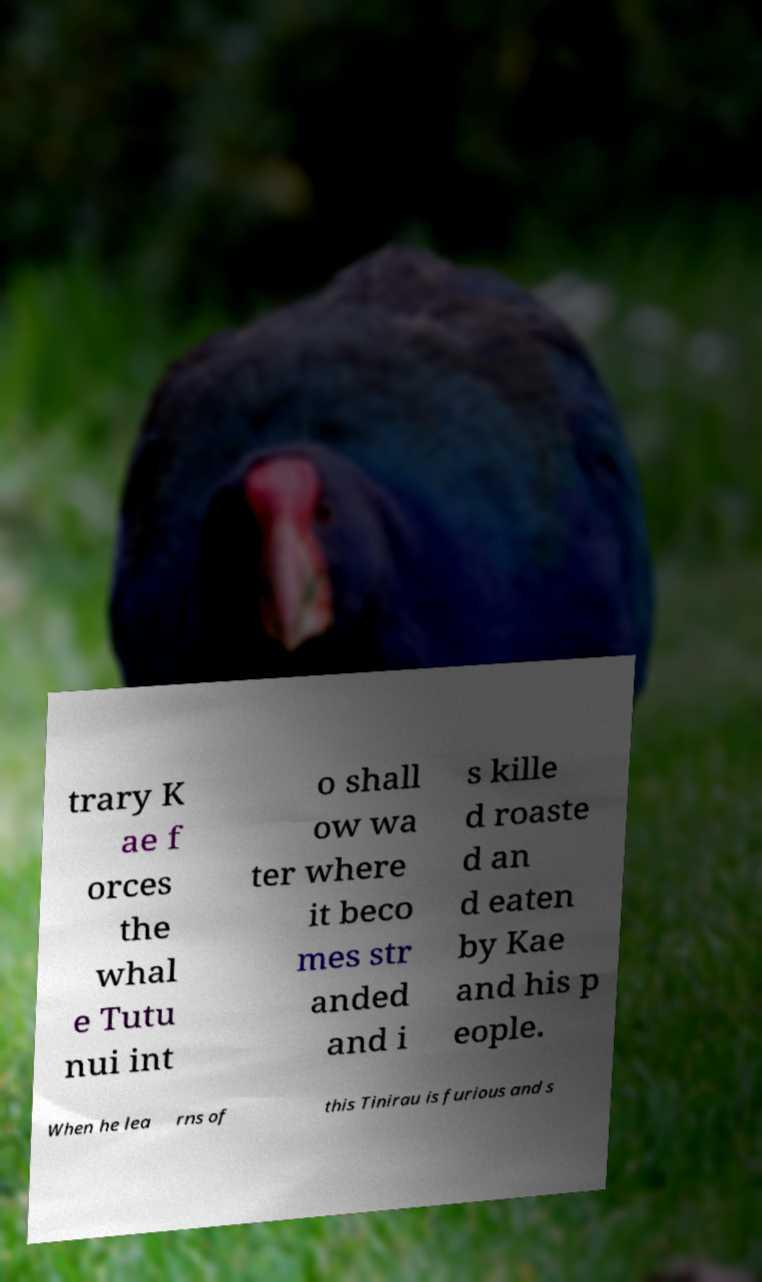Can you accurately transcribe the text from the provided image for me? trary K ae f orces the whal e Tutu nui int o shall ow wa ter where it beco mes str anded and i s kille d roaste d an d eaten by Kae and his p eople. When he lea rns of this Tinirau is furious and s 